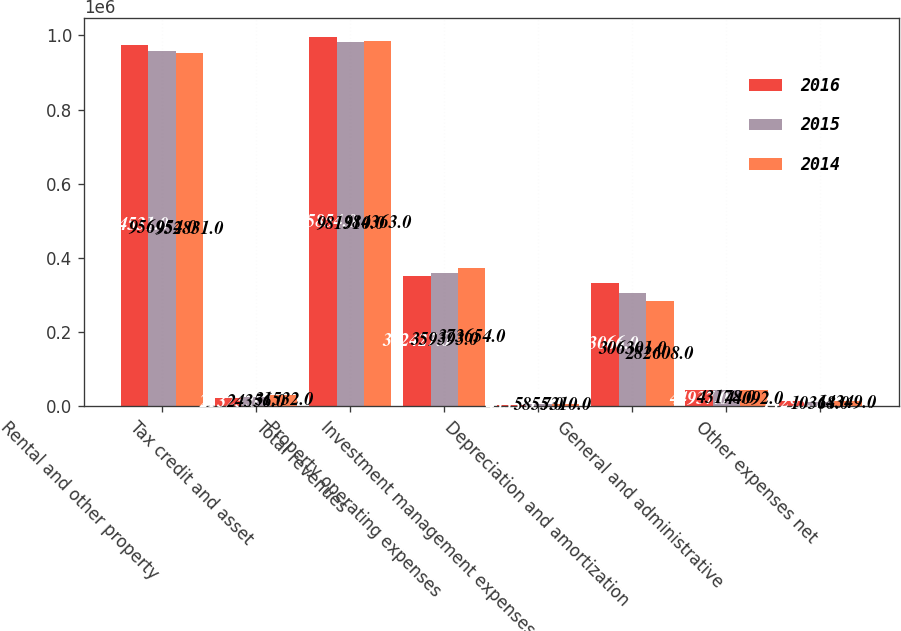<chart> <loc_0><loc_0><loc_500><loc_500><stacked_bar_chart><ecel><fcel>Rental and other property<fcel>Tax credit and asset<fcel>Total revenues<fcel>Property operating expenses<fcel>Investment management expenses<fcel>Depreciation and amortization<fcel>General and administrative<fcel>Other expenses net<nl><fcel>2016<fcel>974531<fcel>21323<fcel>995854<fcel>352427<fcel>4333<fcel>333066<fcel>44937<fcel>14295<nl><fcel>2015<fcel>956954<fcel>24356<fcel>981310<fcel>359393<fcel>5855<fcel>306301<fcel>43178<fcel>10368<nl><fcel>2014<fcel>952831<fcel>31532<fcel>984363<fcel>373654<fcel>7310<fcel>282608<fcel>44092<fcel>14349<nl></chart> 